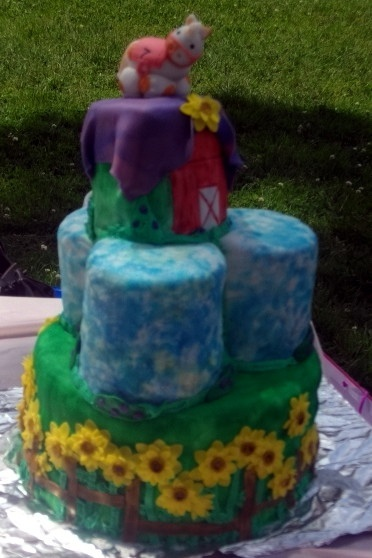Describe the objects in this image and their specific colors. I can see cake in darkgreen, black, olive, and teal tones, cake in darkgreen, black, maroon, and purple tones, cake in darkgreen, blue, darkblue, teal, and lightblue tones, and teddy bear in darkgreen, maroon, gray, brown, and purple tones in this image. 